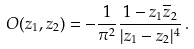Convert formula to latex. <formula><loc_0><loc_0><loc_500><loc_500>O ( z _ { 1 } , z _ { 2 } ) = - \frac { 1 } { \pi ^ { 2 } } \frac { 1 - z _ { 1 } \overline { z } _ { 2 } } { | z _ { 1 } - z _ { 2 } | ^ { 4 } } \, .</formula> 